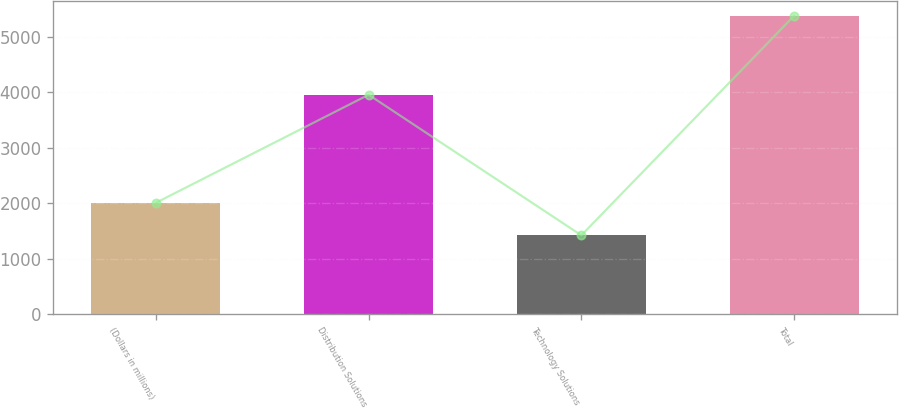Convert chart to OTSL. <chart><loc_0><loc_0><loc_500><loc_500><bar_chart><fcel>(Dollars in millions)<fcel>Distribution Solutions<fcel>Technology Solutions<fcel>Total<nl><fcel>2009<fcel>3955<fcel>1423<fcel>5378<nl></chart> 